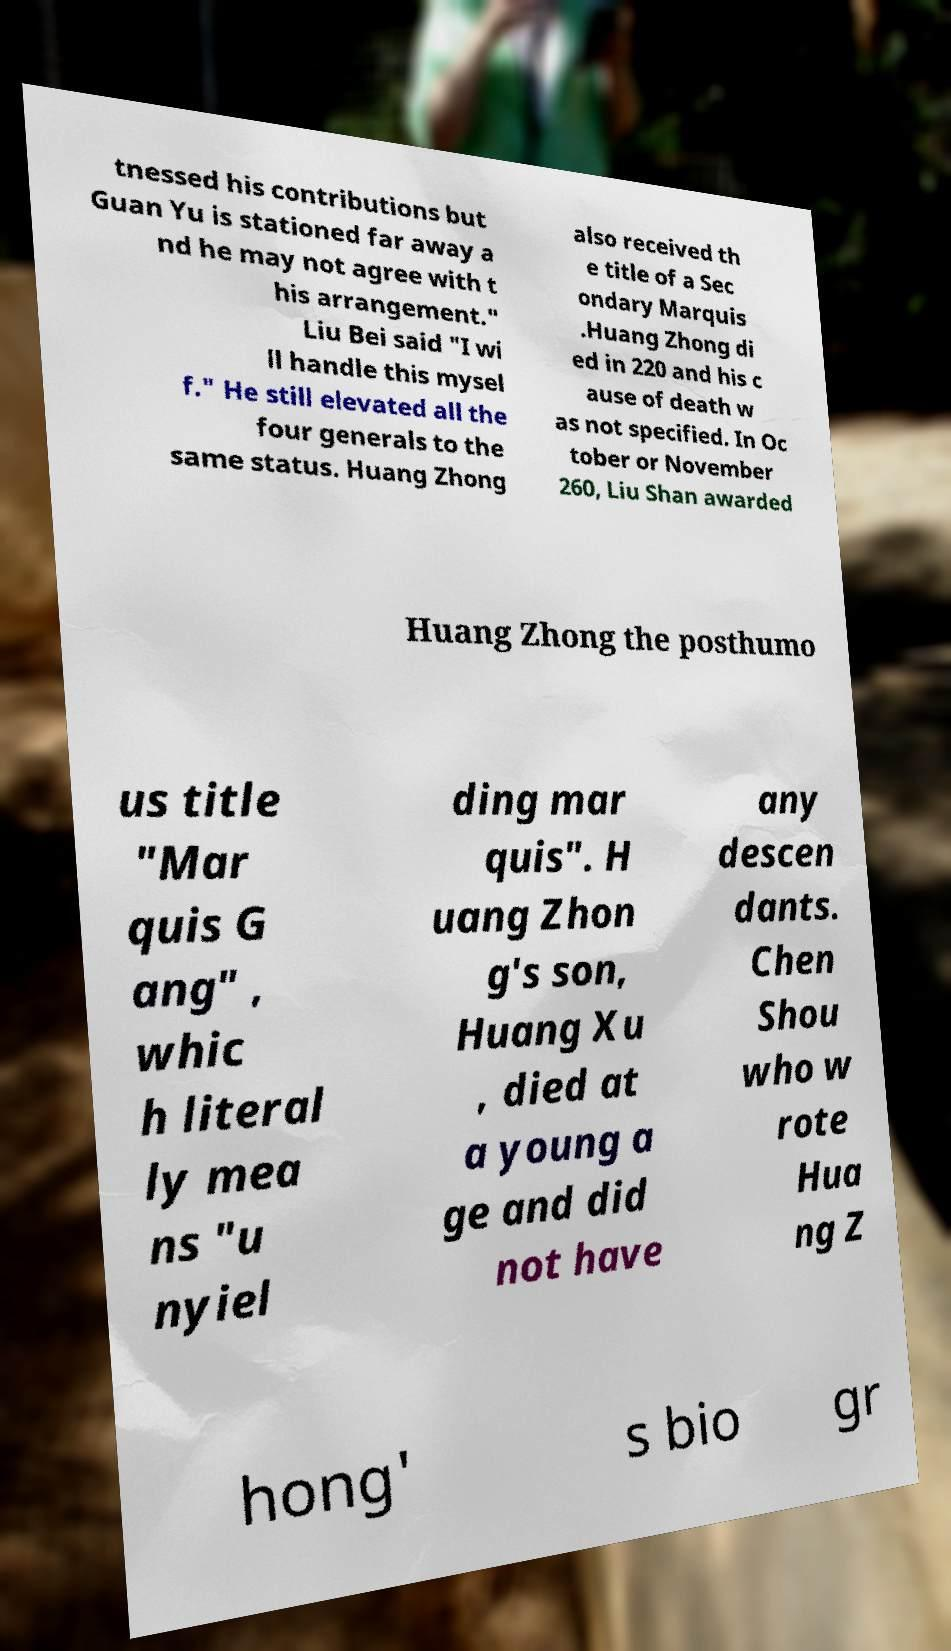What messages or text are displayed in this image? I need them in a readable, typed format. tnessed his contributions but Guan Yu is stationed far away a nd he may not agree with t his arrangement." Liu Bei said "I wi ll handle this mysel f." He still elevated all the four generals to the same status. Huang Zhong also received th e title of a Sec ondary Marquis .Huang Zhong di ed in 220 and his c ause of death w as not specified. In Oc tober or November 260, Liu Shan awarded Huang Zhong the posthumo us title "Mar quis G ang" , whic h literal ly mea ns "u nyiel ding mar quis". H uang Zhon g's son, Huang Xu , died at a young a ge and did not have any descen dants. Chen Shou who w rote Hua ng Z hong' s bio gr 